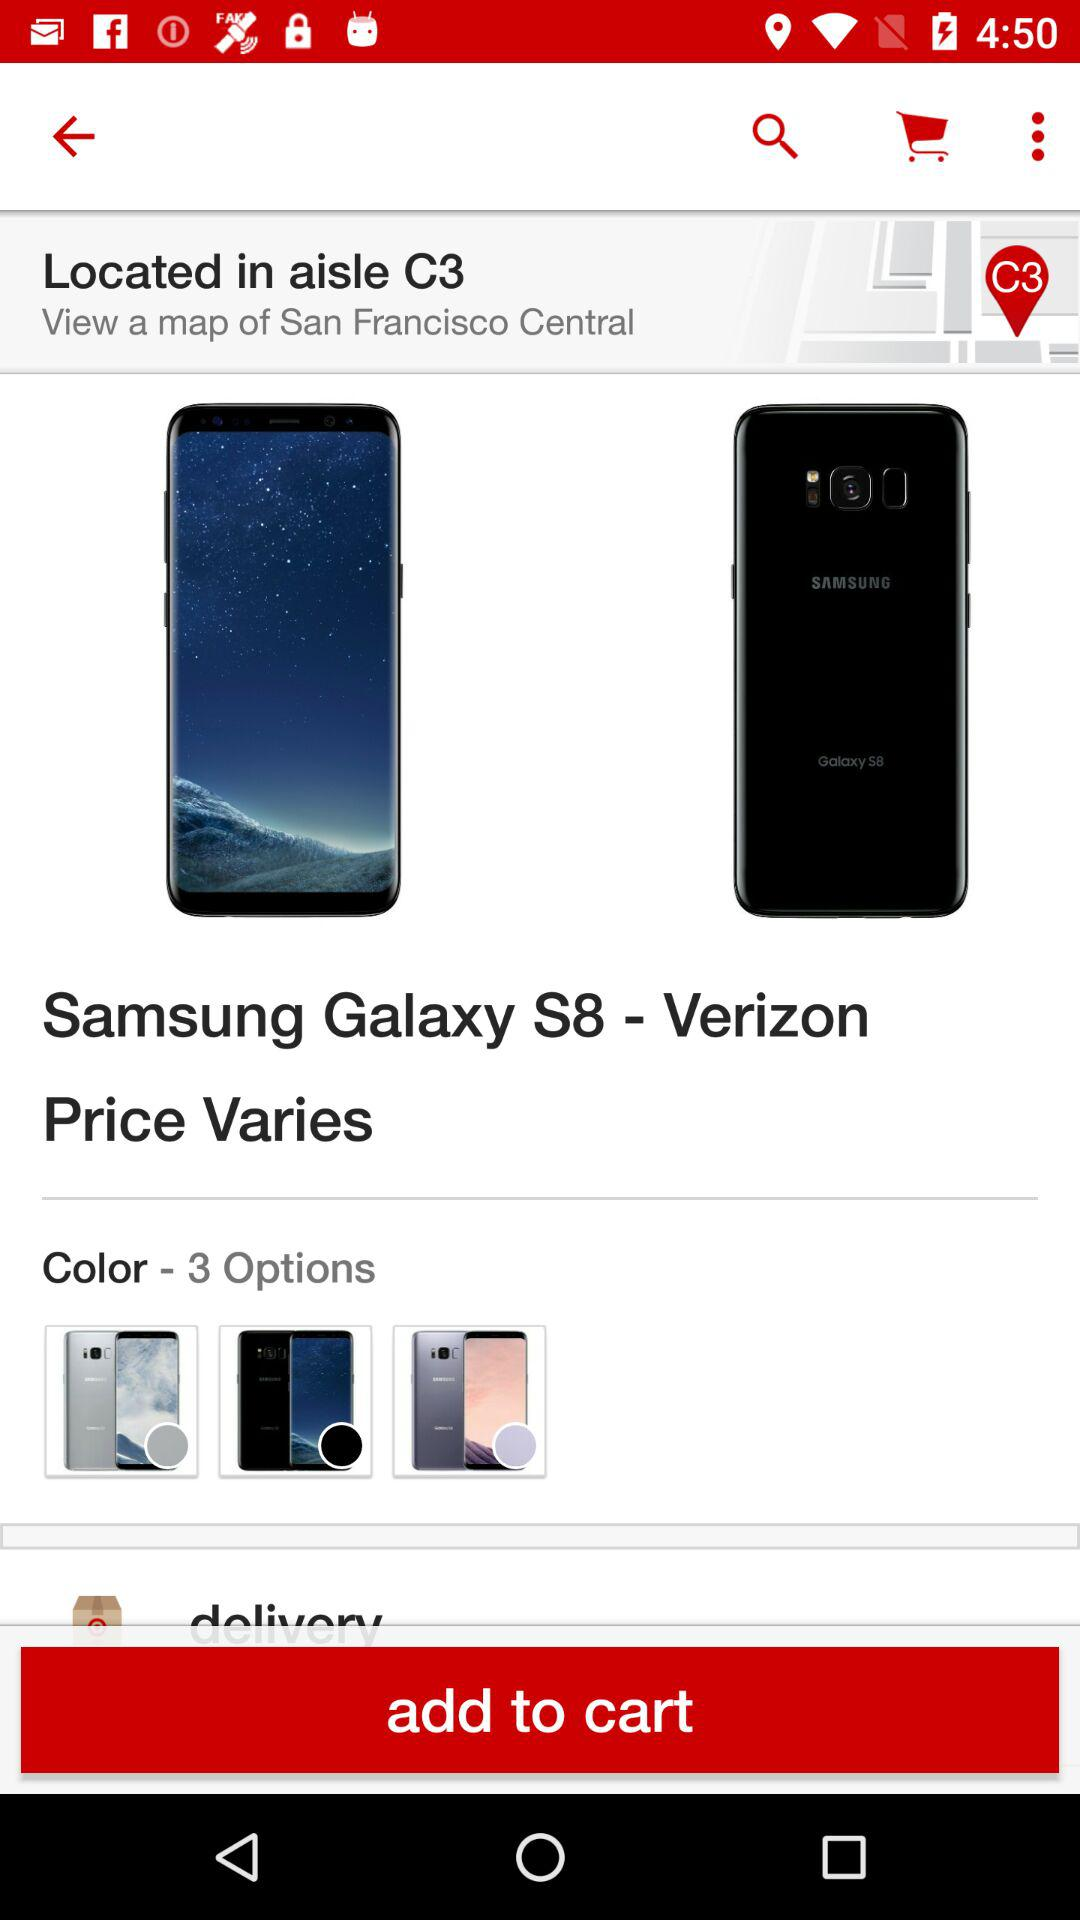How many different options are there for color?
Answer the question using a single word or phrase. 3 